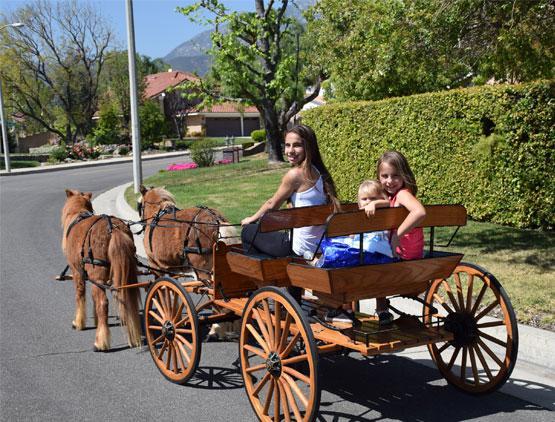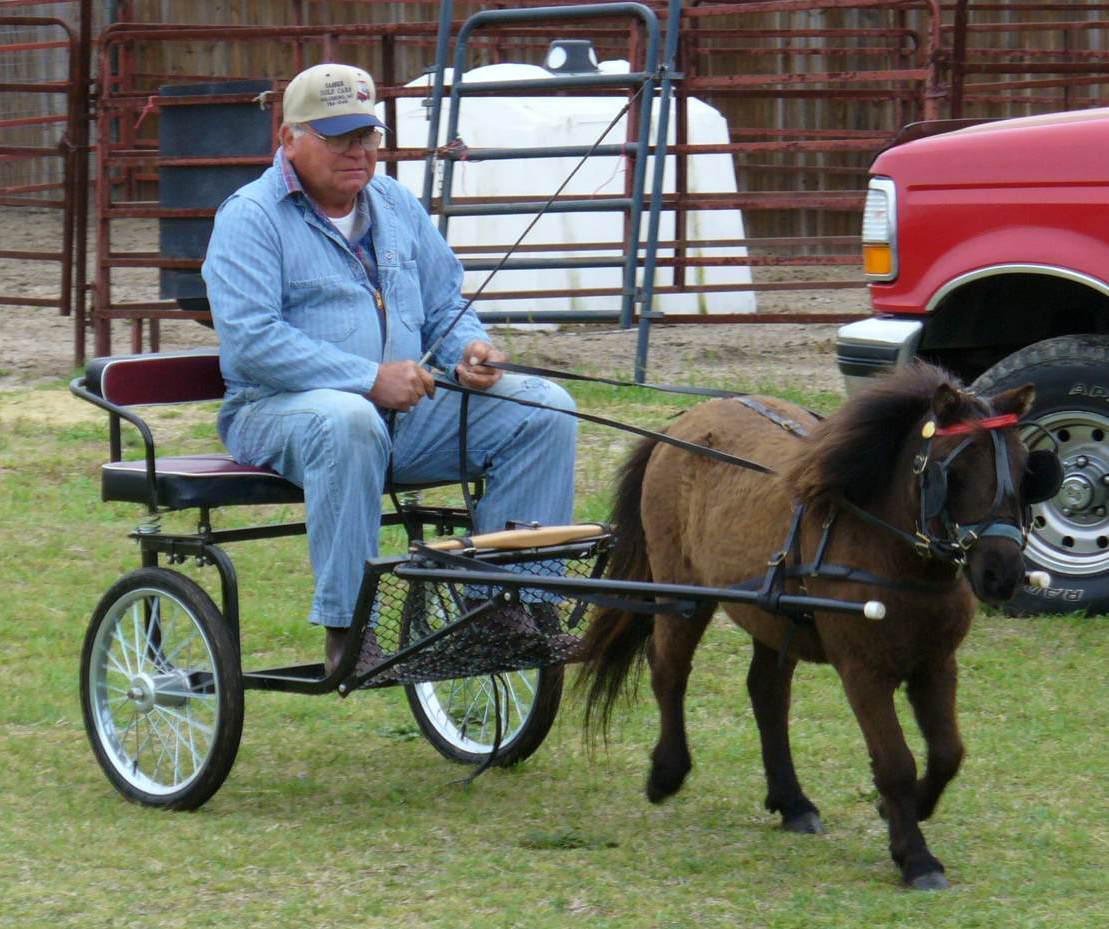The first image is the image on the left, the second image is the image on the right. Analyze the images presented: Is the assertion "A man in a hat is riding on the seat of a leftward-facing four-wheeled wagon pulled by one small black pony." valid? Answer yes or no. No. 